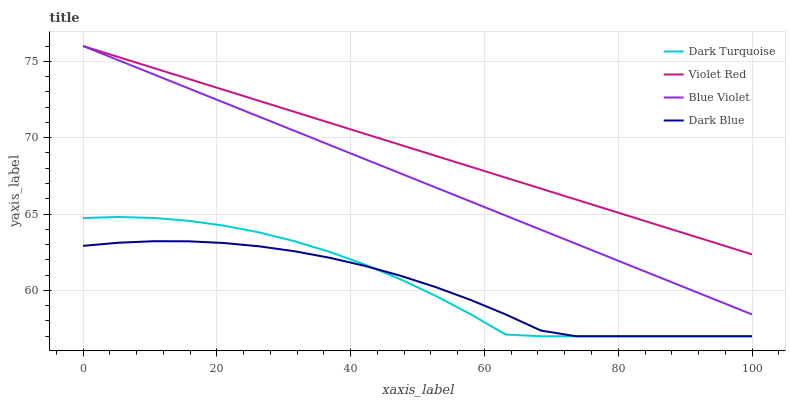Does Dark Blue have the minimum area under the curve?
Answer yes or no. Yes. Does Violet Red have the maximum area under the curve?
Answer yes or no. Yes. Does Blue Violet have the minimum area under the curve?
Answer yes or no. No. Does Blue Violet have the maximum area under the curve?
Answer yes or no. No. Is Blue Violet the smoothest?
Answer yes or no. Yes. Is Dark Turquoise the roughest?
Answer yes or no. Yes. Is Violet Red the smoothest?
Answer yes or no. No. Is Violet Red the roughest?
Answer yes or no. No. Does Dark Turquoise have the lowest value?
Answer yes or no. Yes. Does Blue Violet have the lowest value?
Answer yes or no. No. Does Blue Violet have the highest value?
Answer yes or no. Yes. Does Dark Blue have the highest value?
Answer yes or no. No. Is Dark Blue less than Blue Violet?
Answer yes or no. Yes. Is Violet Red greater than Dark Blue?
Answer yes or no. Yes. Does Violet Red intersect Blue Violet?
Answer yes or no. Yes. Is Violet Red less than Blue Violet?
Answer yes or no. No. Is Violet Red greater than Blue Violet?
Answer yes or no. No. Does Dark Blue intersect Blue Violet?
Answer yes or no. No. 